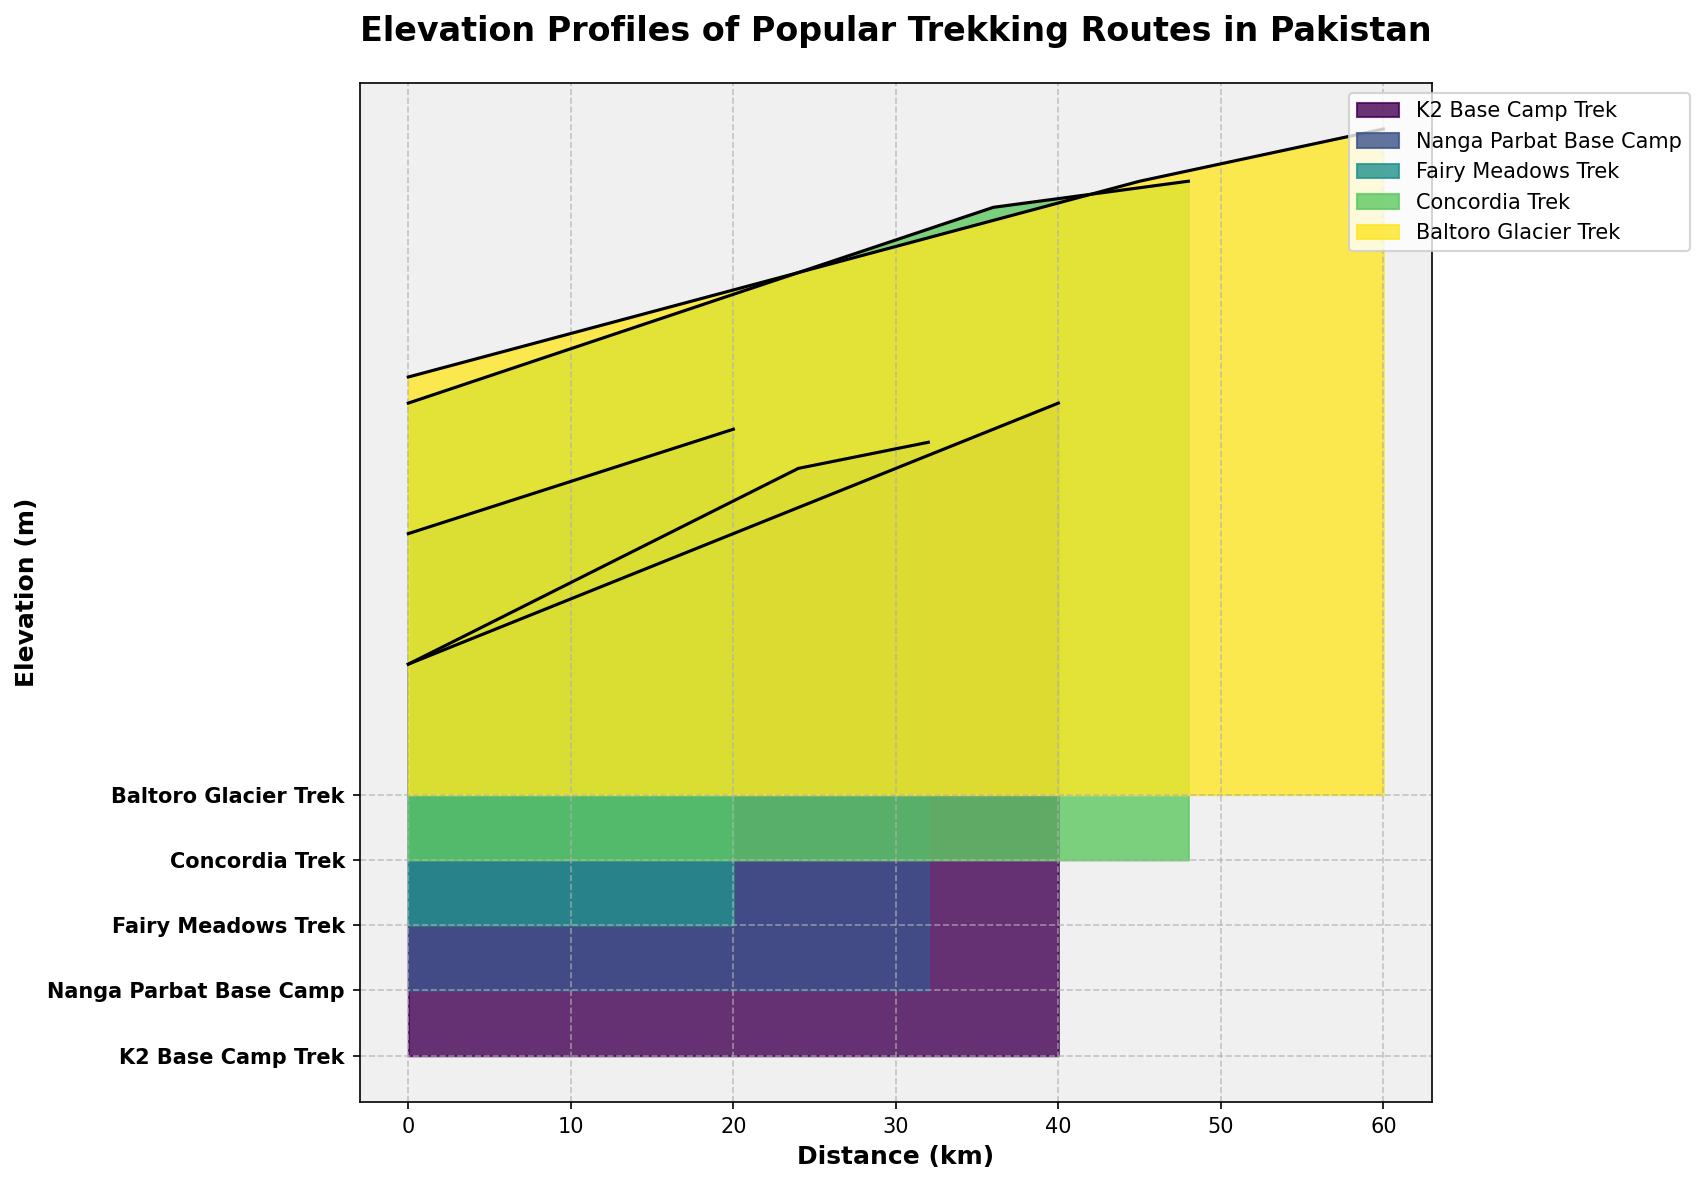Which route starts at the lowest elevation? By looking at the leftmost points on the x-axis, we can see that the "Nanga Parbat Base Camp" starts at 2500 meters, which is the lowest among all the routes.
Answer: Nanga Parbat Base Camp What is the highest elevation reached by the Concordia Trek? Examining the topmost point of the Concordia Trek's line, we see it reaches 5200 meters.
Answer: 5200 meters Which trek covers the longest distance? By comparing the x-axis endpoints of each trek, the "Baltoro Glacier Trek" extends up to 60 km, the longest among all routes.
Answer: Baltoro Glacier Trek By how much does the elevation change from the start to the end of the Fairy Meadows Trek? The elevation at the start is 3000 meters and at the end is 3800 meters. The difference is 3800 - 3000 = 800 meters.
Answer: 800 meters Which trek has the steepest initial ascent? Looking at the slope of the elevation profiles near the start (leftmost part of the plot), the K2 Base Camp Trek has the steepest initial ascent as its elevation increases sharply from 3000 to 3500 meters within the first 10 km.
Answer: K2 Base Camp Trek What is the average elevation change per kilometer for the Nanga Parbat Base Camp from start to end? The total elevation change is 4200 - 2500 = 1700 meters over 32 kilometers. The average change per km is 1700 / 32 ≈ 53.1 meters per km.
Answer: 53.1 meters per kilometer Which route maintains the most consistent elevation gain throughout the trek? By examining the smoothness and consistent slope of the profiles, the Fairy Meadows Trek shows a steady and consistent elevation gain throughout its distance.
Answer: Fairy Meadows Trek At what distance does the Baltoro Glacier Trek reach an elevation of approximately 5000 meters? Following the Baltoro Glacier Trek's elevation profile, it reaches around 5000 meters between distances of 45 and 60 km.
Answer: Between 45 and 60 km How does the elevation profile of the K2 Base Camp Trek compare to the Concordia Trek? Both profiles show a significant ascent, with K2 Base Camp Trek peaking at 5000 meters and Concordia Trek at 5200 meters, but the Concordia Trek reaches a slightly higher maximum elevation.
Answer: Concordia Trek is higher What is the general trend observed in all the trekking routes' elevation profiles? The general trend in the elevation profiles of all the routes is an upward slope, indicating that all routes gain elevation as the trek progresses.
Answer: Upward slope 